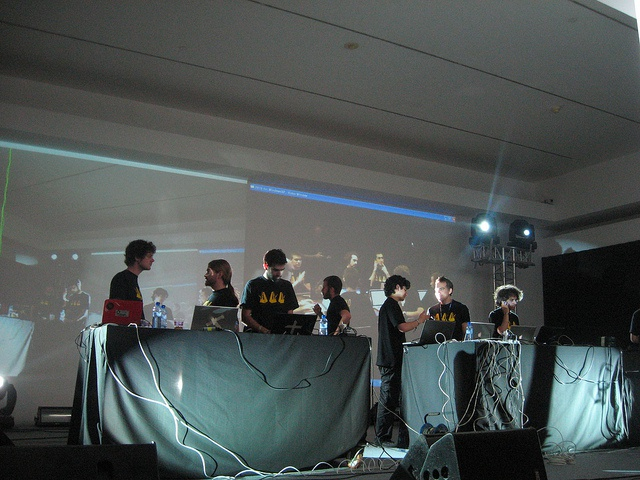Describe the objects in this image and their specific colors. I can see people in black, gray, purple, and darkgray tones, people in black, maroon, gray, and olive tones, people in black, maroon, and gray tones, people in black, gray, and maroon tones, and people in black, gray, white, and darkgray tones in this image. 